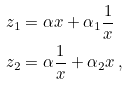Convert formula to latex. <formula><loc_0><loc_0><loc_500><loc_500>z _ { 1 } & = \alpha x + \alpha _ { 1 } \frac { 1 } { x } \\ z _ { 2 } & = \alpha \frac { 1 } { x } + \alpha _ { 2 } x \, ,</formula> 